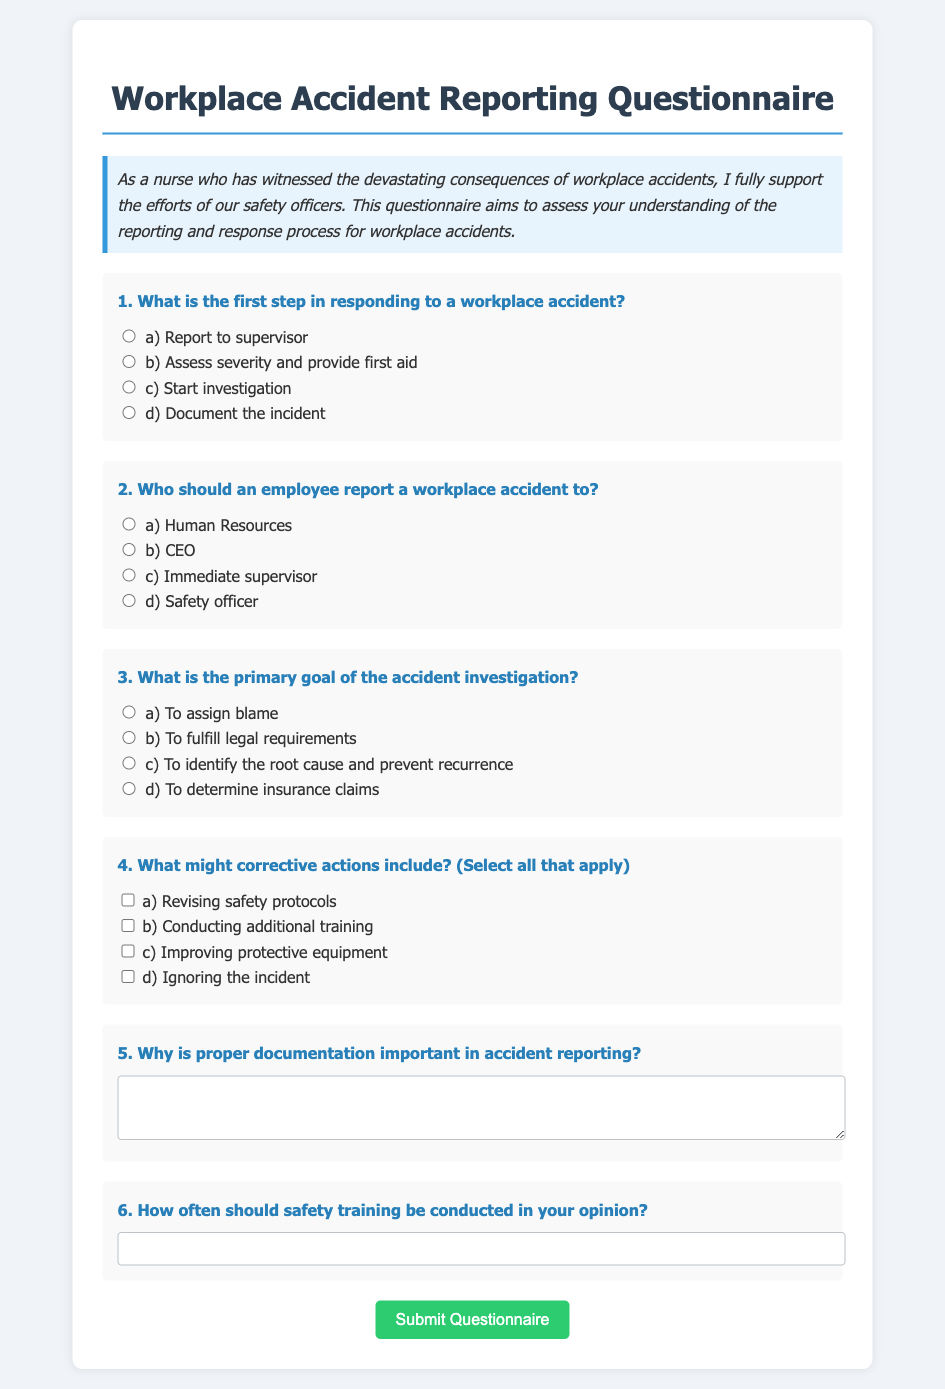What is the title of the document? The title of the document can be found at the top of the rendered questionnaire.
Answer: Workplace Accident Reporting Questionnaire What is the primary goal of an accident investigation according to option C? This goal is clearly mentioned in option C of question 3 in the document.
Answer: To identify the root cause and prevent recurrence Who should employees report a workplace accident to according to option C? The document specifies whom to report to in question 2, option C.
Answer: Immediate supervisor What is one example of a corrective action listed in the questionnaire? The document lists corrective actions in question 4, and option A is one of them.
Answer: Revising safety protocols How many checkboxes are available for corrective actions? The number of checkboxes indicates how many options are available to select in question 4.
Answer: Four 